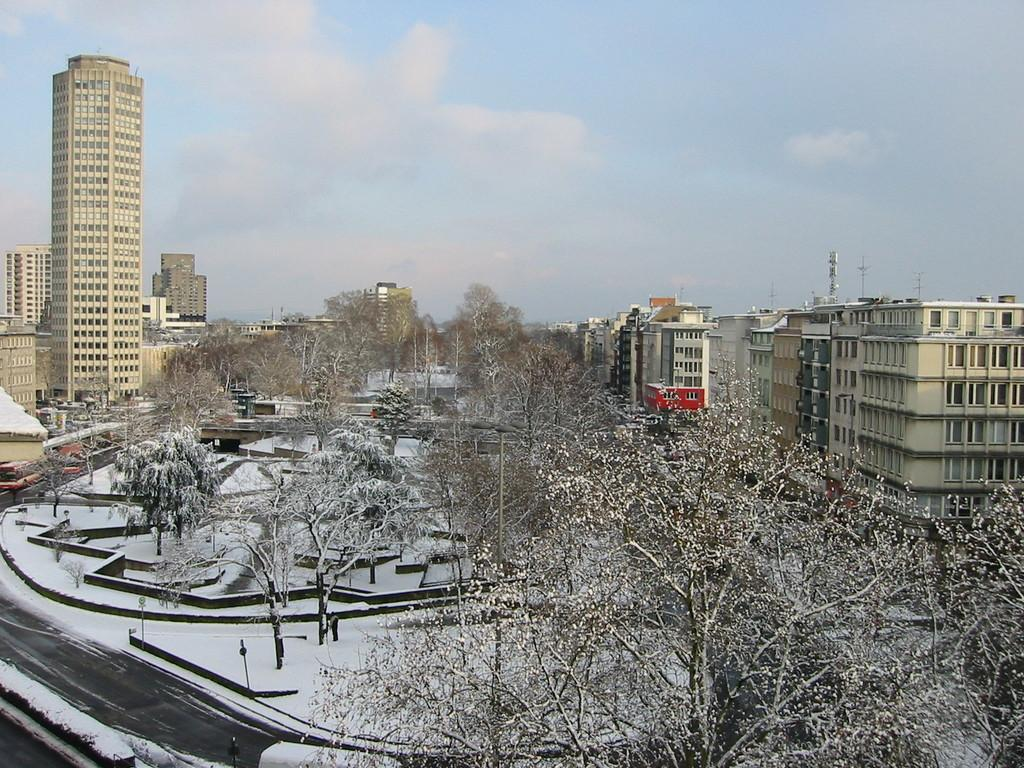What type of vegetation can be seen in the image? There are trees in the image. How is the road depicted in the image? The road is covered with snow in the image. What can be seen in the background of the image? There are buildings and the sky visible in the background of the image. What is the condition of the sky in the image? Clouds are present in the sky in the image. Where is the faucet located in the image? There is no faucet present in the image. What reward can be seen in the image? There is no reward visible in the image. 